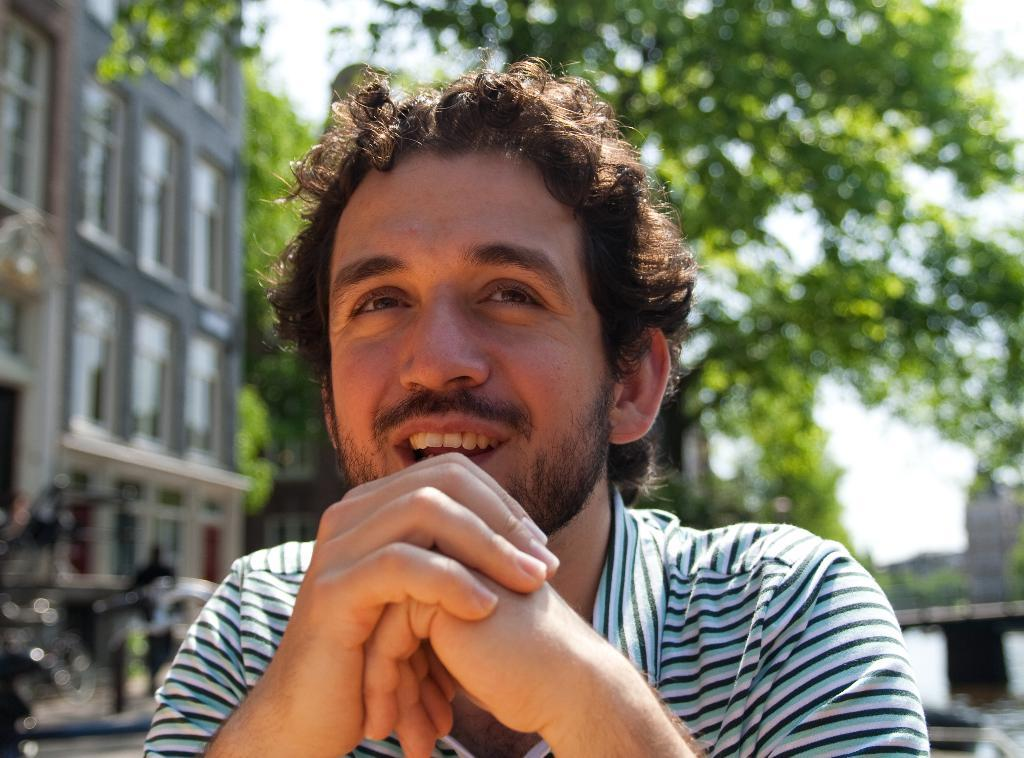Who is present in the image? There is a man in the image. What can be seen in the background of the image? There are trees, buildings, and the sky visible in the background of the image. What type of mint is growing on the man's tooth in the image? There is no mint or tooth present in the image, and therefore no such detail can be observed. 